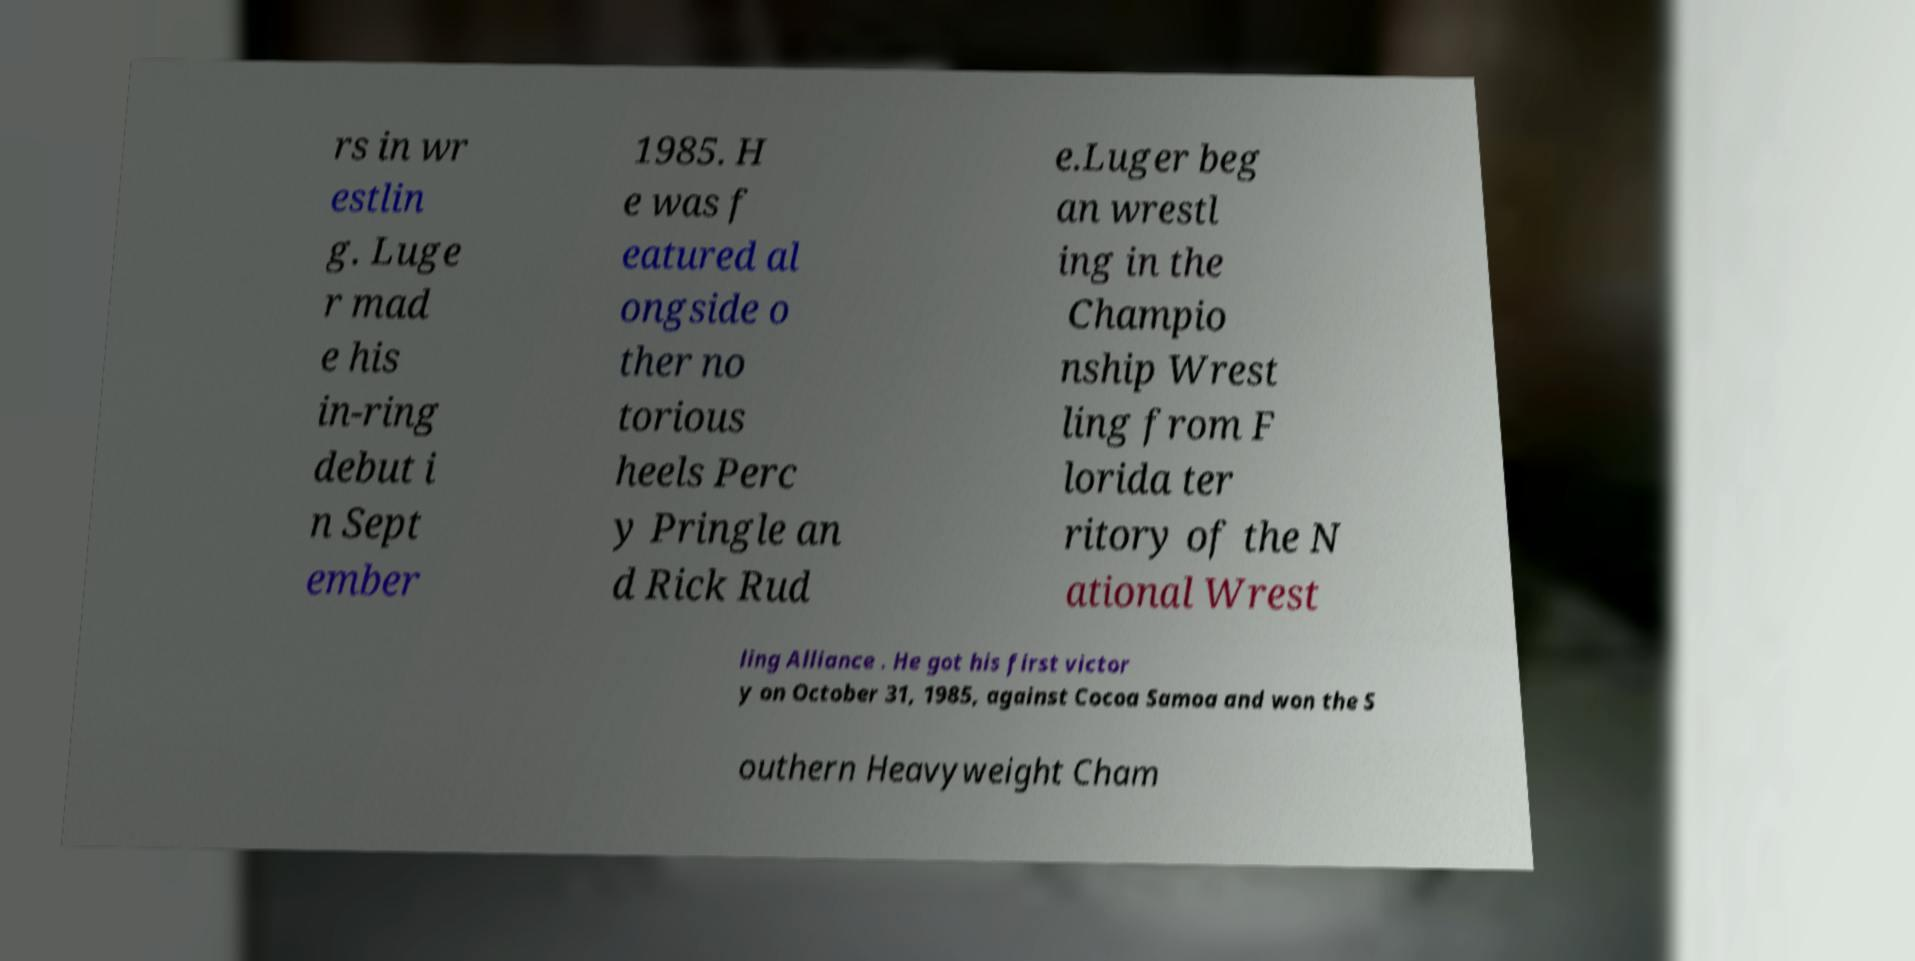I need the written content from this picture converted into text. Can you do that? rs in wr estlin g. Luge r mad e his in-ring debut i n Sept ember 1985. H e was f eatured al ongside o ther no torious heels Perc y Pringle an d Rick Rud e.Luger beg an wrestl ing in the Champio nship Wrest ling from F lorida ter ritory of the N ational Wrest ling Alliance . He got his first victor y on October 31, 1985, against Cocoa Samoa and won the S outhern Heavyweight Cham 